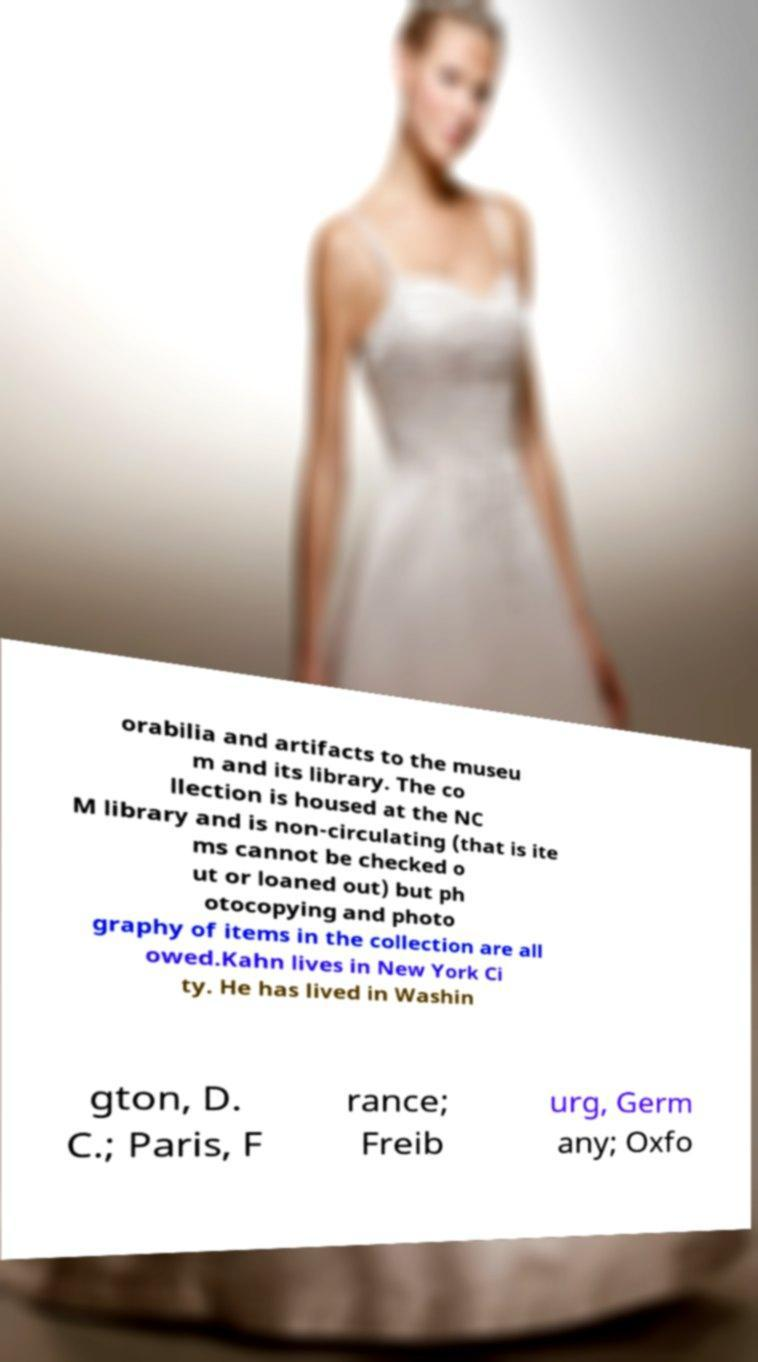For documentation purposes, I need the text within this image transcribed. Could you provide that? orabilia and artifacts to the museu m and its library. The co llection is housed at the NC M library and is non-circulating (that is ite ms cannot be checked o ut or loaned out) but ph otocopying and photo graphy of items in the collection are all owed.Kahn lives in New York Ci ty. He has lived in Washin gton, D. C.; Paris, F rance; Freib urg, Germ any; Oxfo 